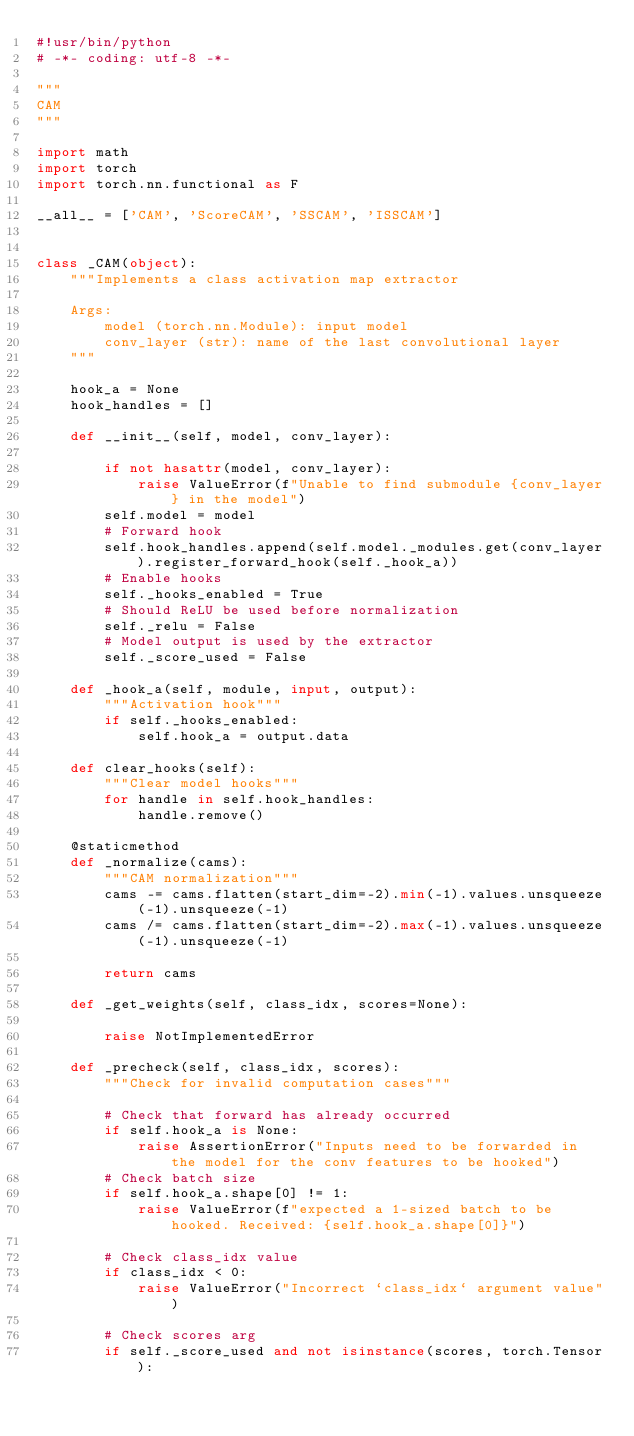<code> <loc_0><loc_0><loc_500><loc_500><_Python_>#!usr/bin/python
# -*- coding: utf-8 -*-

"""
CAM
"""

import math
import torch
import torch.nn.functional as F

__all__ = ['CAM', 'ScoreCAM', 'SSCAM', 'ISSCAM']


class _CAM(object):
    """Implements a class activation map extractor

    Args:
        model (torch.nn.Module): input model
        conv_layer (str): name of the last convolutional layer
    """

    hook_a = None
    hook_handles = []

    def __init__(self, model, conv_layer):

        if not hasattr(model, conv_layer):
            raise ValueError(f"Unable to find submodule {conv_layer} in the model")
        self.model = model
        # Forward hook
        self.hook_handles.append(self.model._modules.get(conv_layer).register_forward_hook(self._hook_a))
        # Enable hooks
        self._hooks_enabled = True
        # Should ReLU be used before normalization
        self._relu = False
        # Model output is used by the extractor
        self._score_used = False

    def _hook_a(self, module, input, output):
        """Activation hook"""
        if self._hooks_enabled:
            self.hook_a = output.data

    def clear_hooks(self):
        """Clear model hooks"""
        for handle in self.hook_handles:
            handle.remove()

    @staticmethod
    def _normalize(cams):
        """CAM normalization"""
        cams -= cams.flatten(start_dim=-2).min(-1).values.unsqueeze(-1).unsqueeze(-1)
        cams /= cams.flatten(start_dim=-2).max(-1).values.unsqueeze(-1).unsqueeze(-1)

        return cams

    def _get_weights(self, class_idx, scores=None):

        raise NotImplementedError

    def _precheck(self, class_idx, scores):
        """Check for invalid computation cases"""

        # Check that forward has already occurred
        if self.hook_a is None:
            raise AssertionError("Inputs need to be forwarded in the model for the conv features to be hooked")
        # Check batch size
        if self.hook_a.shape[0] != 1:
            raise ValueError(f"expected a 1-sized batch to be hooked. Received: {self.hook_a.shape[0]}")

        # Check class_idx value
        if class_idx < 0:
            raise ValueError("Incorrect `class_idx` argument value")

        # Check scores arg
        if self._score_used and not isinstance(scores, torch.Tensor):</code> 